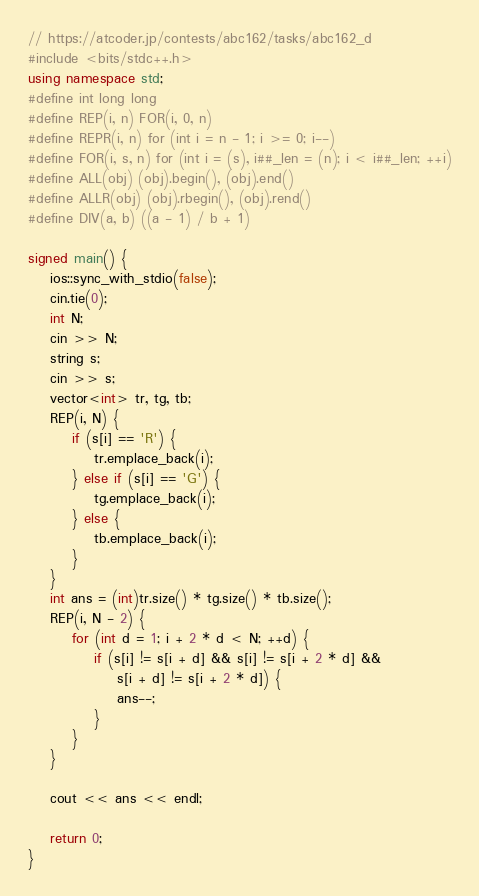<code> <loc_0><loc_0><loc_500><loc_500><_C++_>// https://atcoder.jp/contests/abc162/tasks/abc162_d
#include <bits/stdc++.h>
using namespace std;
#define int long long
#define REP(i, n) FOR(i, 0, n)
#define REPR(i, n) for (int i = n - 1; i >= 0; i--)
#define FOR(i, s, n) for (int i = (s), i##_len = (n); i < i##_len; ++i)
#define ALL(obj) (obj).begin(), (obj).end()
#define ALLR(obj) (obj).rbegin(), (obj).rend()
#define DIV(a, b) ((a - 1) / b + 1)

signed main() {
    ios::sync_with_stdio(false);
    cin.tie(0);
    int N;
    cin >> N;
    string s;
    cin >> s;
    vector<int> tr, tg, tb;
    REP(i, N) {
        if (s[i] == 'R') {
            tr.emplace_back(i);
        } else if (s[i] == 'G') {
            tg.emplace_back(i);
        } else {
            tb.emplace_back(i);
        }
    }
    int ans = (int)tr.size() * tg.size() * tb.size();
    REP(i, N - 2) {
        for (int d = 1; i + 2 * d < N; ++d) {
            if (s[i] != s[i + d] && s[i] != s[i + 2 * d] &&
                s[i + d] != s[i + 2 * d]) {
                ans--;
            }
        }
    }

    cout << ans << endl;

    return 0;
}
</code> 